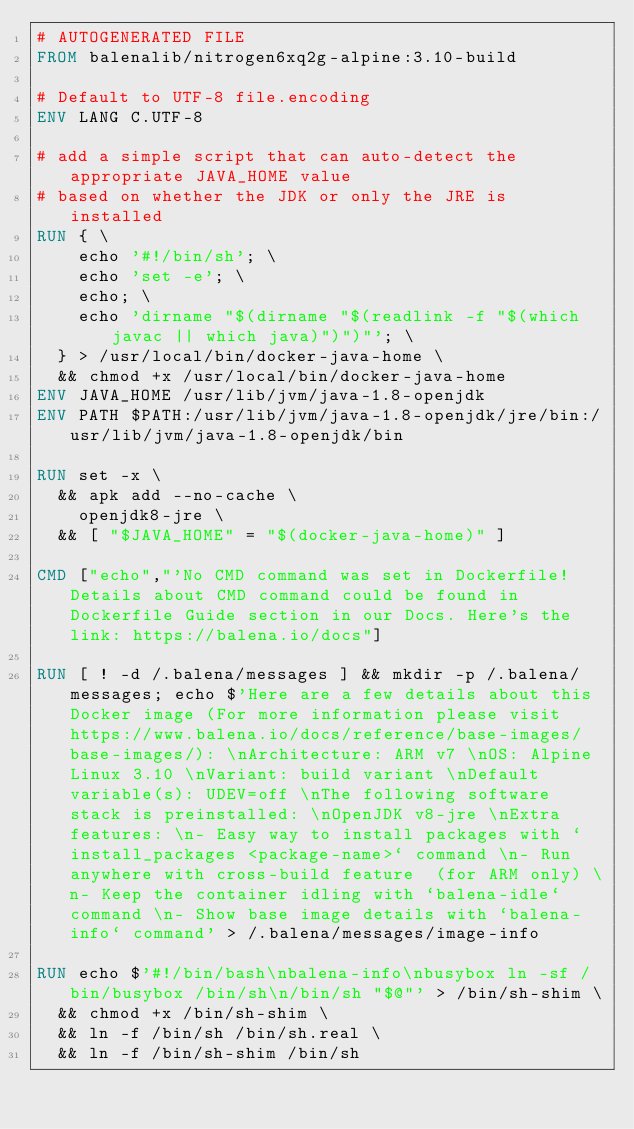Convert code to text. <code><loc_0><loc_0><loc_500><loc_500><_Dockerfile_># AUTOGENERATED FILE
FROM balenalib/nitrogen6xq2g-alpine:3.10-build

# Default to UTF-8 file.encoding
ENV LANG C.UTF-8

# add a simple script that can auto-detect the appropriate JAVA_HOME value
# based on whether the JDK or only the JRE is installed
RUN { \
		echo '#!/bin/sh'; \
		echo 'set -e'; \
		echo; \
		echo 'dirname "$(dirname "$(readlink -f "$(which javac || which java)")")"'; \
	} > /usr/local/bin/docker-java-home \
	&& chmod +x /usr/local/bin/docker-java-home
ENV JAVA_HOME /usr/lib/jvm/java-1.8-openjdk
ENV PATH $PATH:/usr/lib/jvm/java-1.8-openjdk/jre/bin:/usr/lib/jvm/java-1.8-openjdk/bin

RUN set -x \
	&& apk add --no-cache \
		openjdk8-jre \
	&& [ "$JAVA_HOME" = "$(docker-java-home)" ]

CMD ["echo","'No CMD command was set in Dockerfile! Details about CMD command could be found in Dockerfile Guide section in our Docs. Here's the link: https://balena.io/docs"]

RUN [ ! -d /.balena/messages ] && mkdir -p /.balena/messages; echo $'Here are a few details about this Docker image (For more information please visit https://www.balena.io/docs/reference/base-images/base-images/): \nArchitecture: ARM v7 \nOS: Alpine Linux 3.10 \nVariant: build variant \nDefault variable(s): UDEV=off \nThe following software stack is preinstalled: \nOpenJDK v8-jre \nExtra features: \n- Easy way to install packages with `install_packages <package-name>` command \n- Run anywhere with cross-build feature  (for ARM only) \n- Keep the container idling with `balena-idle` command \n- Show base image details with `balena-info` command' > /.balena/messages/image-info

RUN echo $'#!/bin/bash\nbalena-info\nbusybox ln -sf /bin/busybox /bin/sh\n/bin/sh "$@"' > /bin/sh-shim \
	&& chmod +x /bin/sh-shim \
	&& ln -f /bin/sh /bin/sh.real \
	&& ln -f /bin/sh-shim /bin/sh</code> 